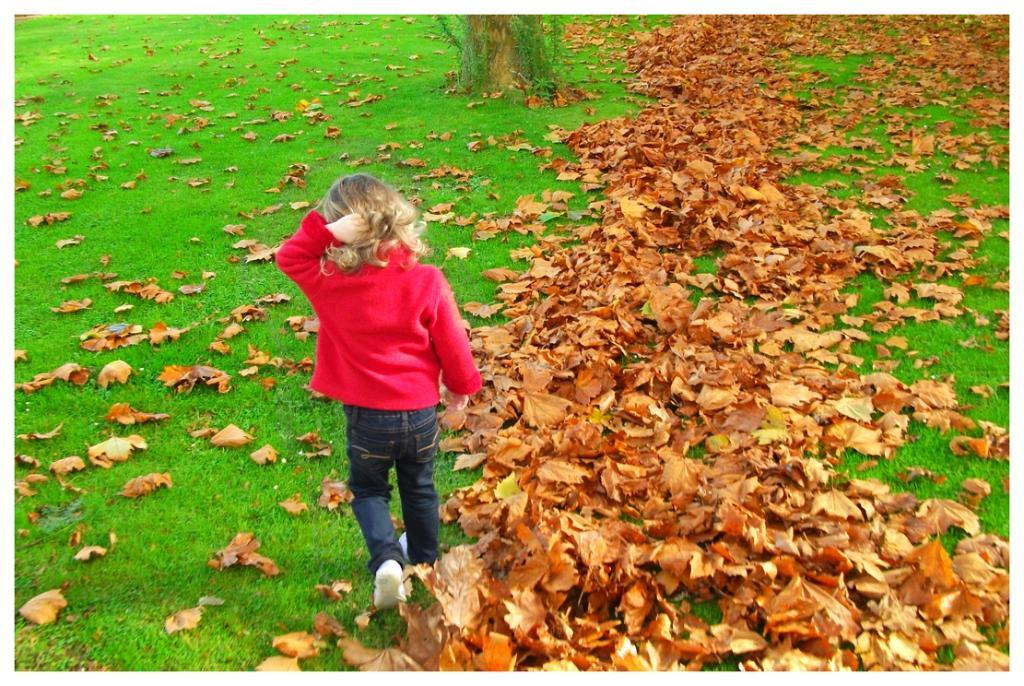Who is present in the image? There is a girl standing in the image. What type of vegetation can be seen in the image? There is grass and leaves in the image. What part of a tree is visible in the image? There is a tree trunk in the image. What type of rice is being cooked in the image? There is no rice present in the image. What is the tendency of the rock in the image? There is no rock present in the image. 